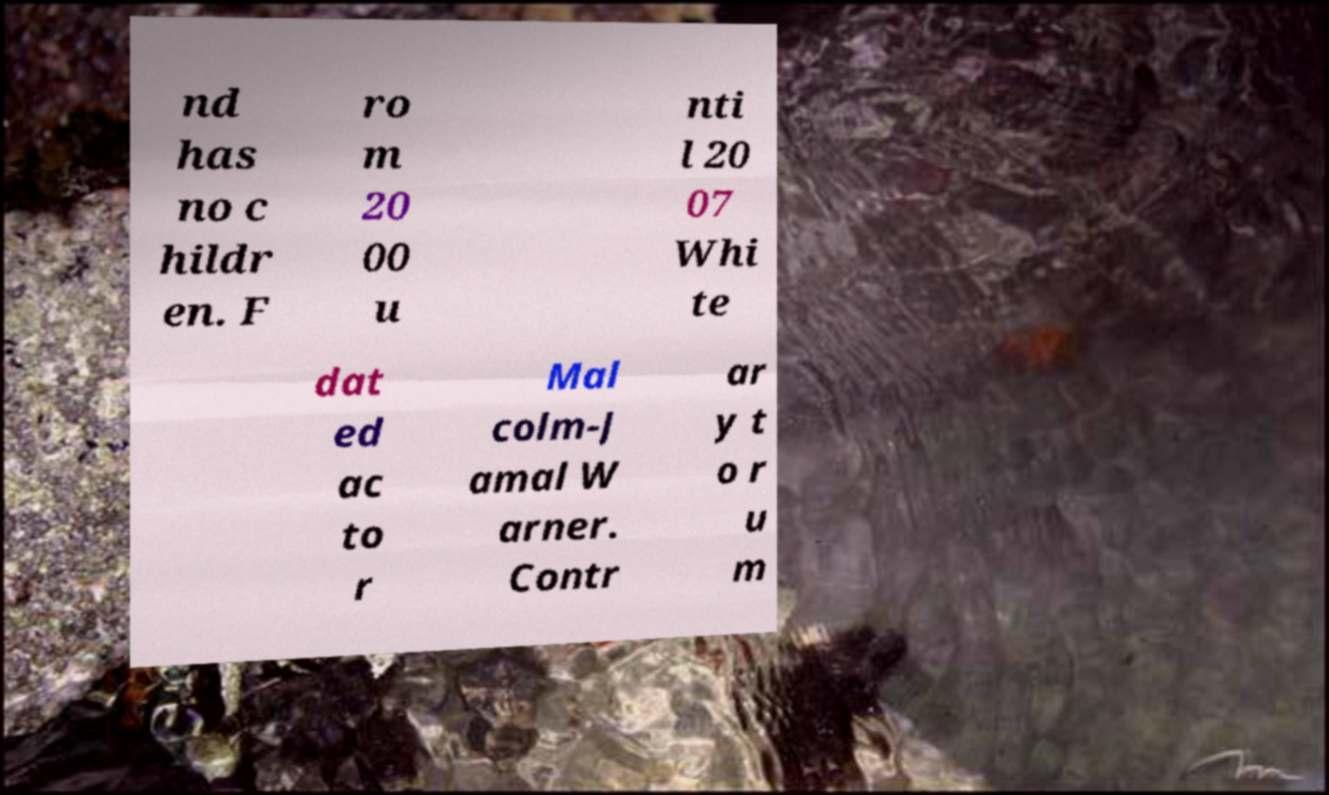For documentation purposes, I need the text within this image transcribed. Could you provide that? nd has no c hildr en. F ro m 20 00 u nti l 20 07 Whi te dat ed ac to r Mal colm-J amal W arner. Contr ar y t o r u m 